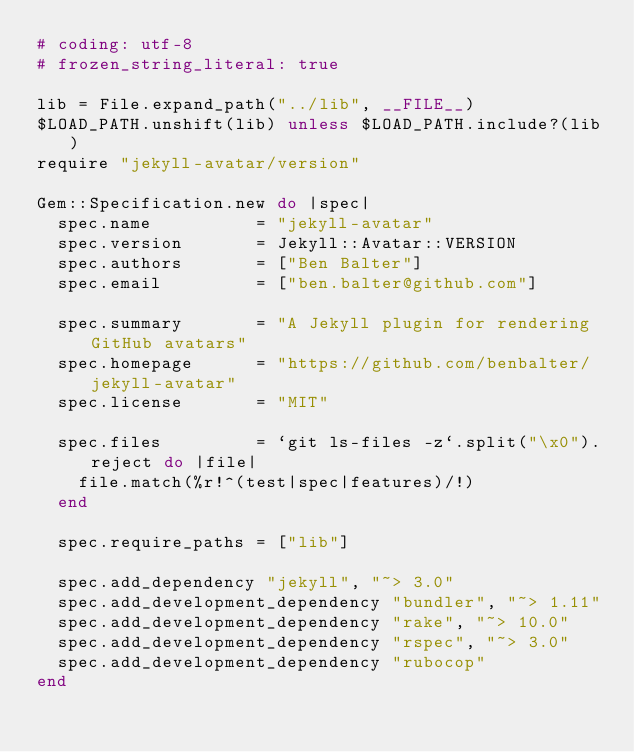<code> <loc_0><loc_0><loc_500><loc_500><_Ruby_># coding: utf-8
# frozen_string_literal: true

lib = File.expand_path("../lib", __FILE__)
$LOAD_PATH.unshift(lib) unless $LOAD_PATH.include?(lib)
require "jekyll-avatar/version"

Gem::Specification.new do |spec|
  spec.name          = "jekyll-avatar"
  spec.version       = Jekyll::Avatar::VERSION
  spec.authors       = ["Ben Balter"]
  spec.email         = ["ben.balter@github.com"]

  spec.summary       = "A Jekyll plugin for rendering GitHub avatars"
  spec.homepage      = "https://github.com/benbalter/jekyll-avatar"
  spec.license       = "MIT"

  spec.files         = `git ls-files -z`.split("\x0").reject do |file|
    file.match(%r!^(test|spec|features)/!)
  end

  spec.require_paths = ["lib"]

  spec.add_dependency "jekyll", "~> 3.0"
  spec.add_development_dependency "bundler", "~> 1.11"
  spec.add_development_dependency "rake", "~> 10.0"
  spec.add_development_dependency "rspec", "~> 3.0"
  spec.add_development_dependency "rubocop"
end
</code> 